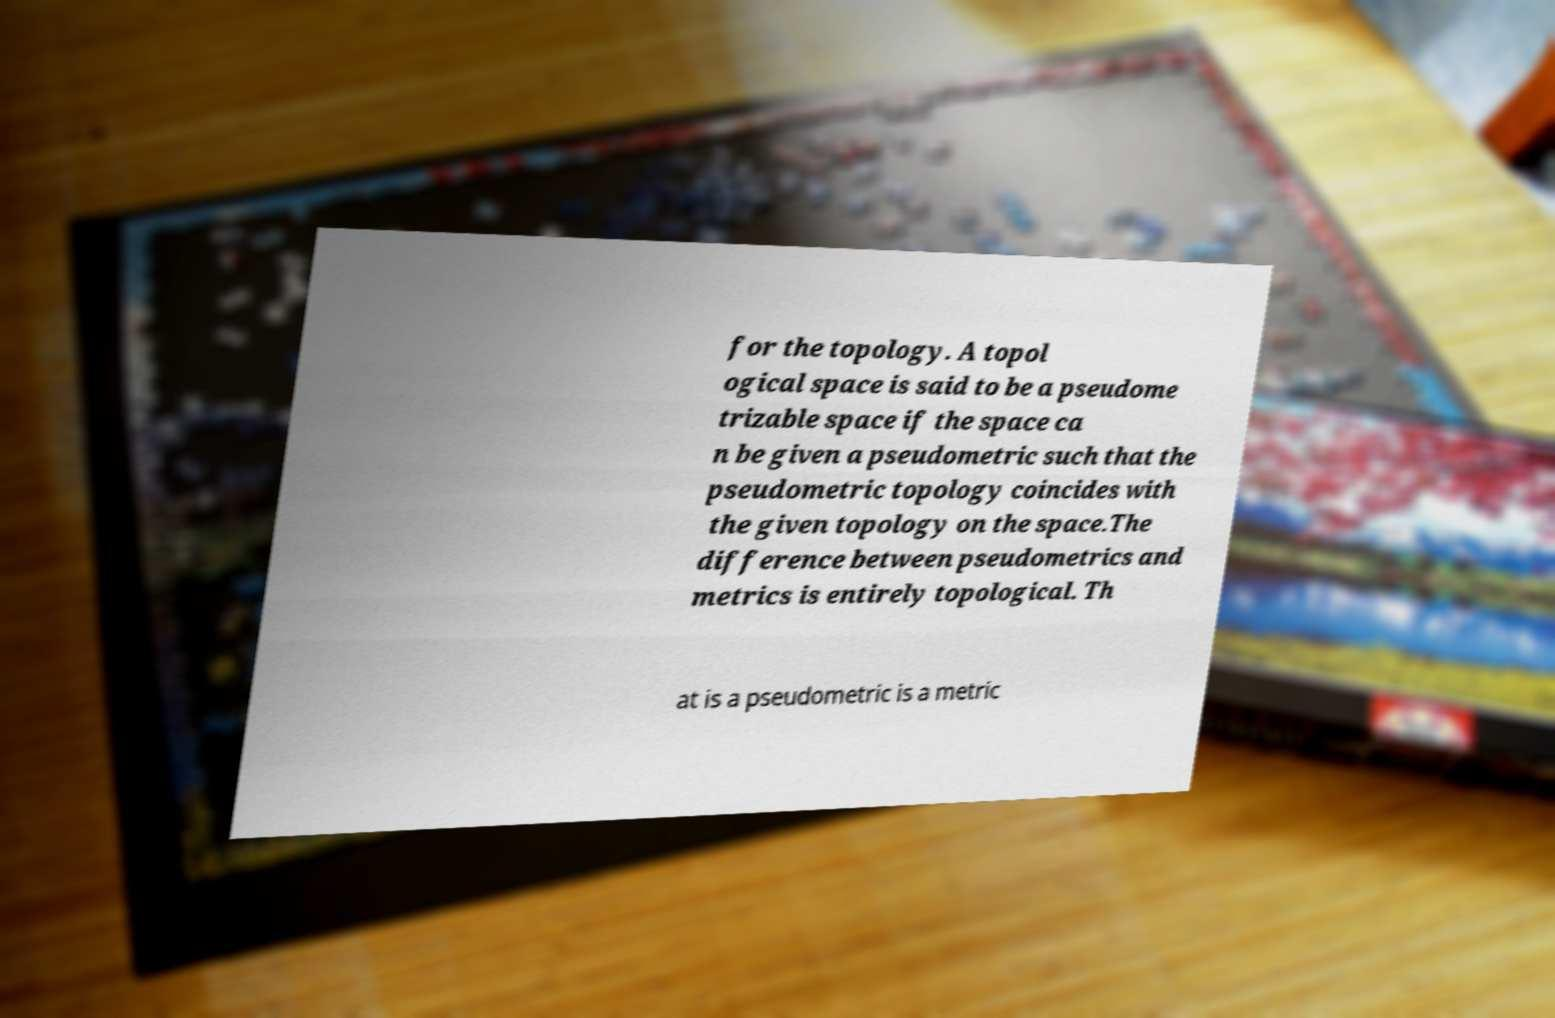Could you assist in decoding the text presented in this image and type it out clearly? for the topology. A topol ogical space is said to be a pseudome trizable space if the space ca n be given a pseudometric such that the pseudometric topology coincides with the given topology on the space.The difference between pseudometrics and metrics is entirely topological. Th at is a pseudometric is a metric 